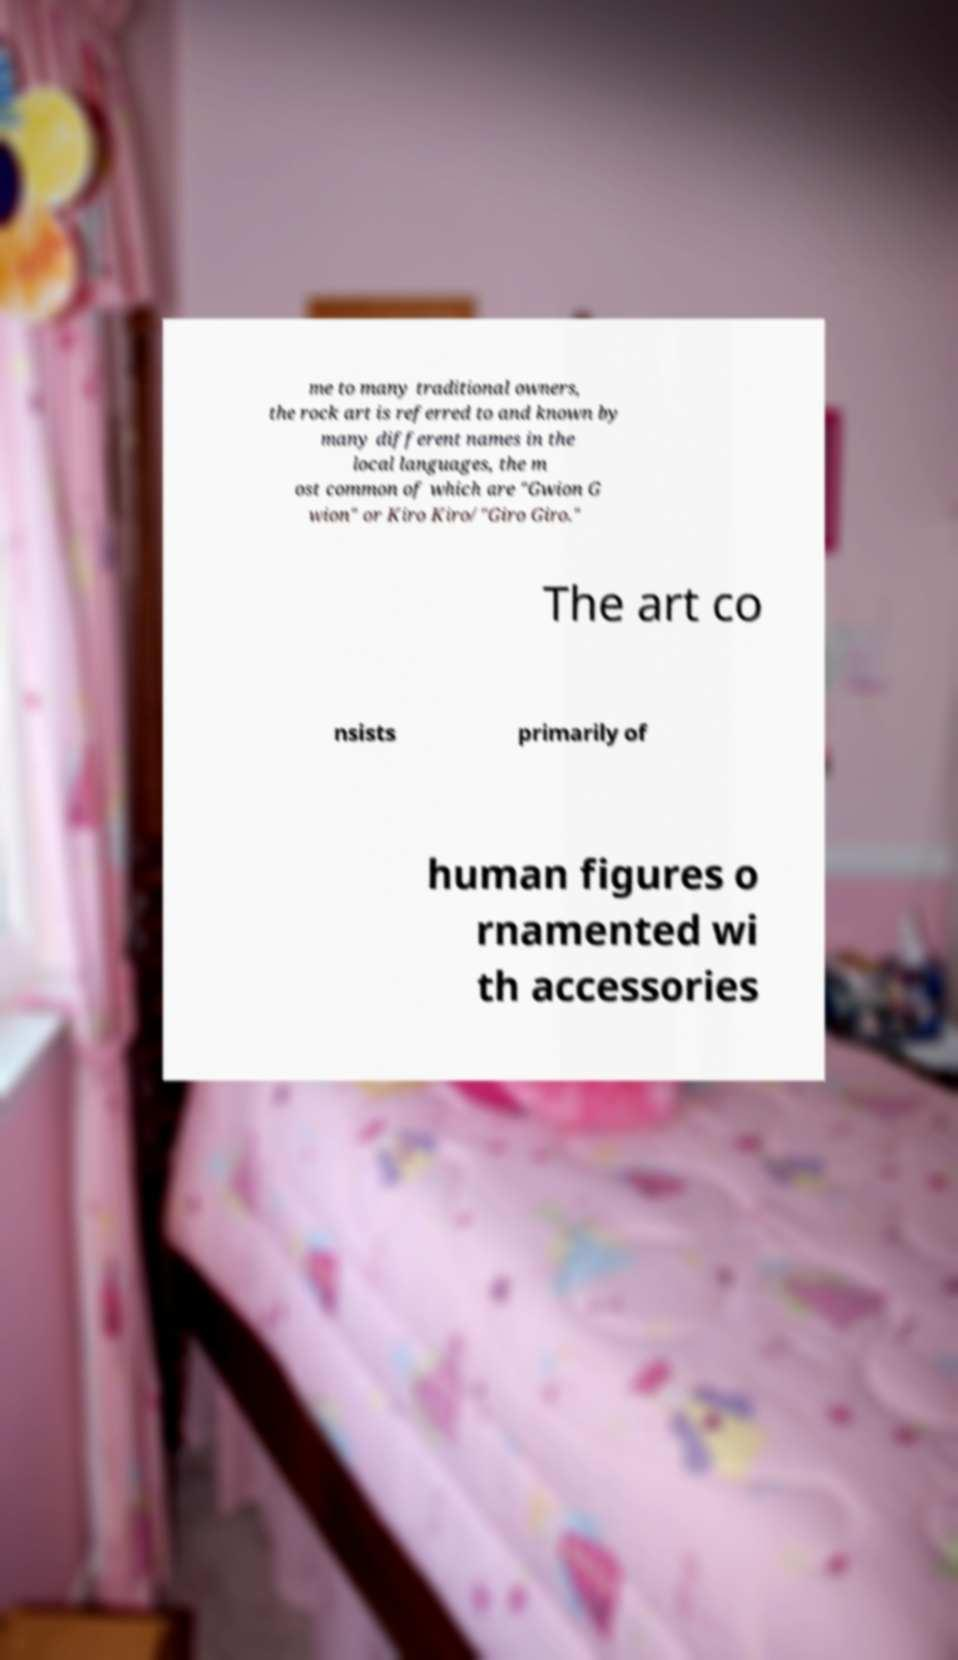There's text embedded in this image that I need extracted. Can you transcribe it verbatim? me to many traditional owners, the rock art is referred to and known by many different names in the local languages, the m ost common of which are "Gwion G wion" or Kiro Kiro/"Giro Giro." The art co nsists primarily of human figures o rnamented wi th accessories 